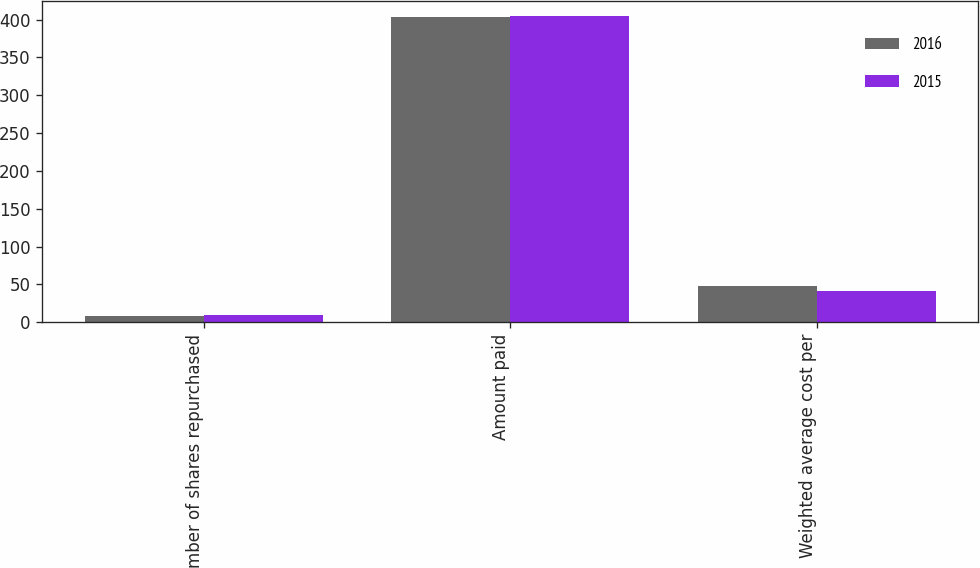Convert chart. <chart><loc_0><loc_0><loc_500><loc_500><stacked_bar_chart><ecel><fcel>Number of shares repurchased<fcel>Amount paid<fcel>Weighted average cost per<nl><fcel>2016<fcel>8.4<fcel>403.8<fcel>48.56<nl><fcel>2015<fcel>9.8<fcel>404.7<fcel>41.39<nl></chart> 